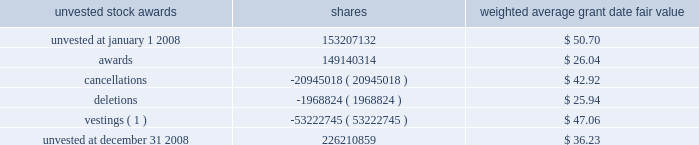Employees .
As explained below , pursuant to sfas 123 ( r ) , the charge to income for awards made to retirement-eligible employees is accelerated based on the dates the retirement rules are met .
Cap and certain other awards provide that participants who meet certain age and years of service conditions may continue to vest in all or a portion of the award without remaining employed by the company during the entire vesting period , so long as they do not compete with citigroup during that time .
Beginning in 2006 , awards to these retirement-eligible employees are recognized in the year prior to the grant in the same manner as cash incentive compensation is accrued .
However , awards granted in january 2006 were required to be expensed in their entirety at the date of grant .
Prior to 2006 , all awards were recognized ratably over the stated vesting period .
See note 1 to the consolidated financial statements on page 122 for the impact of adopting sfas 123 ( r ) .
From 2003 to 2007 , citigroup granted restricted or deferred shares annually under the citigroup ownership program ( cop ) to eligible employees .
This program replaced the wealthbuilder , citibuilder and citigroup ownership stock option programs .
Under cop , eligible employees received either restricted or deferred shares of citigroup common stock that vest after three years .
The last award under this program was in 2007 .
Unearned compensation expense associated with the stock grants represents the market value of citigroup common stock at the date of grant and is recognized as a charge to income ratably over the vesting period , except for those awards granted to retirement-eligible employees .
The charge to income for awards made to retirement-eligible employees is accelerated based on the dates the retirement rules are met .
On july 17 , 2007 , the personnel and compensation committee of citigroup 2019s board of directors approved the management committee long- term incentive plan ( mc ltip ) , under the terms of the shareholder- approved 1999 stock incentive plan .
The mc ltip provides members of the citigroup management committee , including the ceo , cfo and the named executive officers in the citigroup proxy statement , an opportunity to earn stock awards based on citigroup 2019s performance .
Each participant received an equity award that will be earned based on citigroup 2019s performance for the period from july 1 , 2007 to december 31 , 2009 .
Three periods will be measured for performance ( july 1 , 2007 to december 31 , 2007 , full year 2008 and full year 2009 ) .
The ultimate value of the award will be based on citigroup 2019s performance in each of these periods with respect to ( 1 ) total shareholder return versus citigroup 2019s current key competitors and ( 2 ) publicly stated return on equity ( roe ) targets measured at the end of each calendar year .
If , in any of the three performance periods , citigroup 2019s total shareholder return does not exceed the median performance of the peer group , the participants will not receive award shares for that period .
The awards will generally vest after 30 months .
In order to receive the shares , a participant generally must be a citigroup employee on january 5 , 2010 .
The final expense for each of the three calendar years will be adjusted based on the results of the roe tests .
No awards were earned for 2008 or 2007 because performance targets were not met .
No new awards were made under the mc ltip since the initial award in july 2007 .
On january 22 , 2008 , special retention stock awards were made to key senior executive officers and certain other members of senior management .
The awards vest ratably over two- or four-year periods .
Executives must remain employed through the vesting dates to receive the shares awarded , except in cases of death , disability , or involuntary termination other than for gross misconduct .
Unlike cap , post-employment vesting is not provided for participants who meet specified age and years of service conditions .
Shares subject to some of the awards are exempted from the stock ownership commitment .
A summary of the status of citigroup 2019s unvested stock awards as of december 31 , 2008 , and changes during the 12 months ended december 31 , 2008 , is presented below : unvested stock awards shares weighted average grant date fair value .
( 1 ) the weighted average market value of the vestings during 2008 was approximately $ 22.31 per share .
As of december 31 , 2008 , there was $ 3.3 billion of total unrecognized compensation cost related to unvested stock awards net of the forfeiture provision .
That cost is expected to be recognized over a weighted-average period of 2.6 years. .
What was the approximate value of the shares that vested during 2008? 
Computations: (53222745 * 22.31)
Answer: 1187399440.95. 